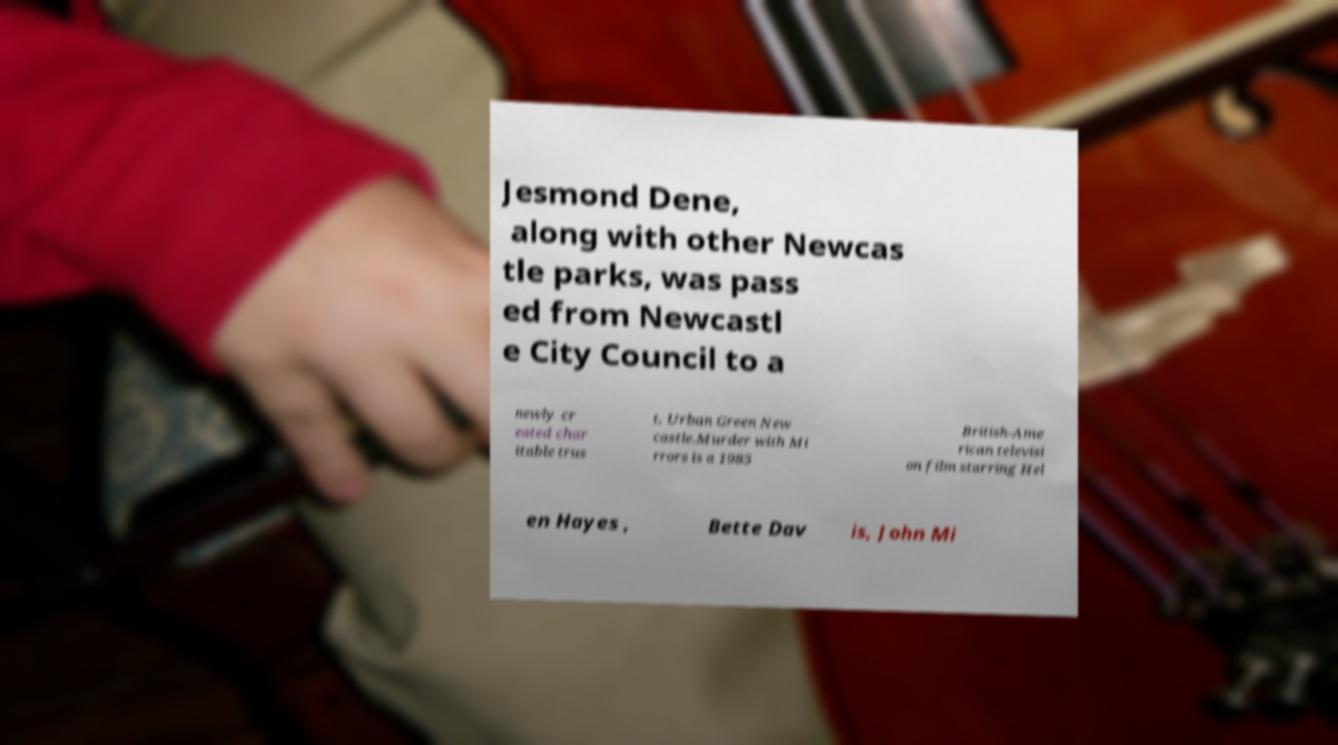Please identify and transcribe the text found in this image. Jesmond Dene, along with other Newcas tle parks, was pass ed from Newcastl e City Council to a newly cr eated char itable trus t, Urban Green New castle.Murder with Mi rrors is a 1985 British-Ame rican televisi on film starring Hel en Hayes , Bette Dav is, John Mi 